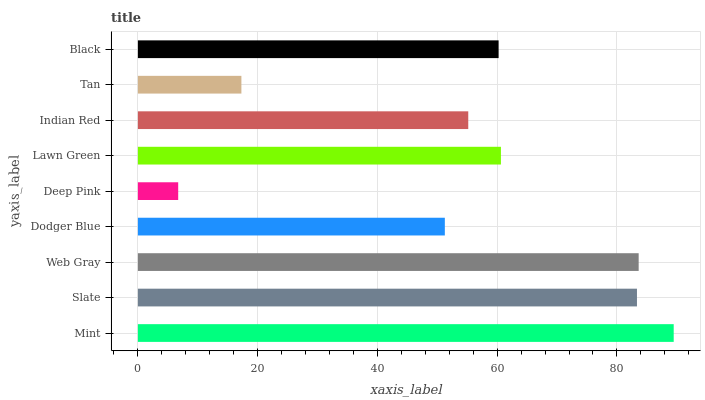Is Deep Pink the minimum?
Answer yes or no. Yes. Is Mint the maximum?
Answer yes or no. Yes. Is Slate the minimum?
Answer yes or no. No. Is Slate the maximum?
Answer yes or no. No. Is Mint greater than Slate?
Answer yes or no. Yes. Is Slate less than Mint?
Answer yes or no. Yes. Is Slate greater than Mint?
Answer yes or no. No. Is Mint less than Slate?
Answer yes or no. No. Is Black the high median?
Answer yes or no. Yes. Is Black the low median?
Answer yes or no. Yes. Is Slate the high median?
Answer yes or no. No. Is Dodger Blue the low median?
Answer yes or no. No. 